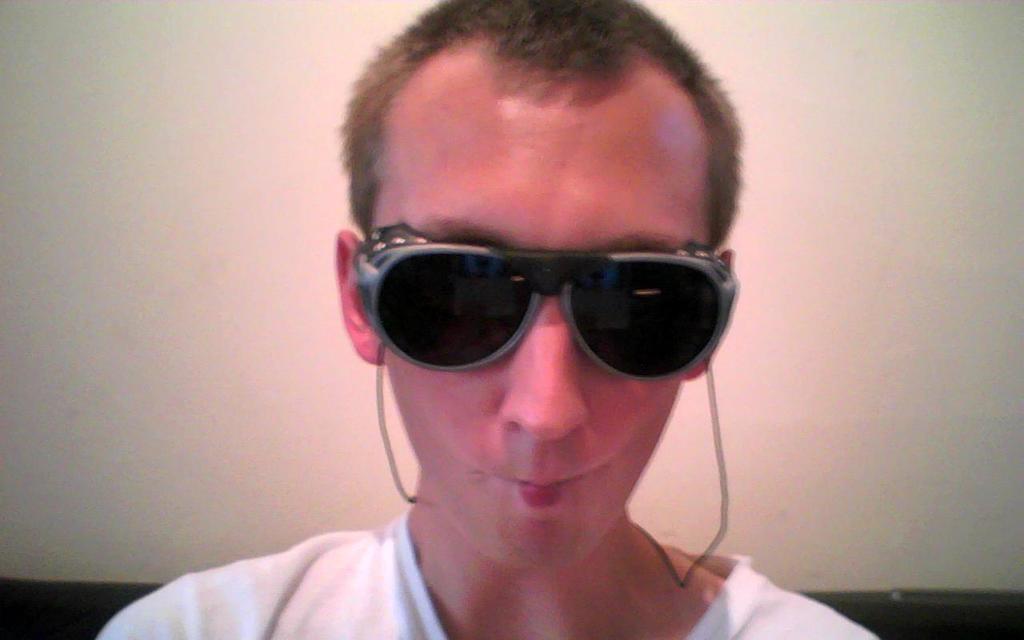Could you give a brief overview of what you see in this image? In this picture I can see a person wearing glasses. I can see the wall in the background. 